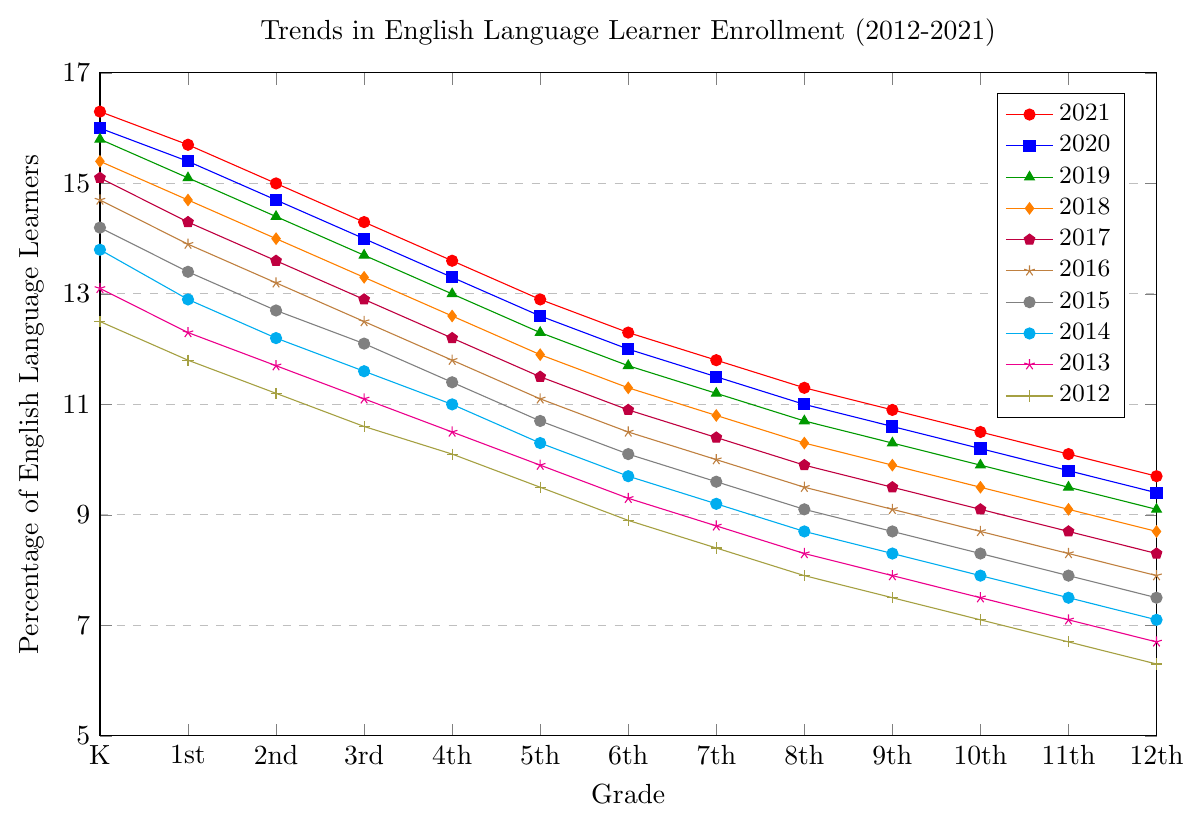What is the trend in the percentage of English Language Learners (ELL) from Kindergarten to 12th grade in the year 2021? To determine this, look at the values on the line labeled "2021" from Kindergarten (16.3%) to 12th grade (9.7%) and observe the pattern. The trend shows a decrease in the percentage of ELL from Kindergarten to 12th grade.
Answer: Decreasing trend Which grade shows the highest percentage of ELL in 2021? Refer to the values labeled "2021" and identify the highest point on the line chart. The highest percentage is at Kindergarten with 16.3%.
Answer: Kindergarten By how much did the percentage of ELL in the 6th grade change from 2012 to 2021? Look at the values for 6th grade in 2012 (8.9%) and 2021 (12.3%). Calculate the difference: 12.3% - 8.9% = 3.4%.
Answer: 3.4% Compare the percentage of ELL in the 5th grade in 2015 and 2020. Which year had a higher percentage and by how much? Examine the values for 5th grade in 2015 (10.7%) and 2020 (12.6%). 2020 had a higher percentage. Calculate the difference: 12.6% - 10.7% = 1.9%.
Answer: 2020, 1.9% What is the average percentage of ELL across all grades in 2021? Sum the percentages for all grades in 2021 (16.3 + 15.7 + 15.0 + 14.3 + 13.6 + 12.9 + 12.3 + 11.8 + 11.3 + 10.9 + 10.5 + 10.1 + 9.7) = 174.4%. There are 13 grades. Divide the sum by 13: 174.4 / 13 ≈ 13.41%.
Answer: 13.41% In which year did the 12th grade have the lowest percentage of ELL? Examine the line for 12th grade and identify the lowest value. The lowest value is in 2012 with 6.3%.
Answer: 2012 Which grade had the smallest increase in ELL percentage from 2012 to 2021? Calculate the increase for each grade: 
- Kindergarten: 16.3 - 12.5 = 3.8
- 1st: 15.7 - 11.8 = 3.9
- 2nd: 15.0 - 11.2 = 3.8
- 3rd: 14.3 - 10.6 = 3.7
- 4th: 13.6 - 10.1 = 3.5
- 5th: 12.9 - 9.5 = 3.4
- 6th: 12.3 - 8.9 = 3.4
- 7th: 11.8 - 8.4 = 3.4
- 8th: 11.3 - 7.9 = 3.4
- 9th: 10.9 - 7.5 = 3.4
- 10th: 10.5 - 7.1 = 3.4
- 11th: 10.1 - 6.7 = 3.4
- 12th: 9.7 - 6.3 = 3.4
The grade with the smallest increase is tied among 5th, 6th, 7th, 8th, 9th, 10th, 11th, and 12th grades, all with an increase of 3.4%.
Answer: 5th, 6th, 7th, 8th, 9th, 10th, 11th, 12th How did the overall trend in the percentage of ELL change from 2012 to 2021 for grades K through 12? Examine the overall trend lines for all grades from 2012 to 2021. Each grade shows an increasing trend in the percentage of ELL over the years.
Answer: Increasing trend What is the median percentage of ELL for the 3rd grade from 2012 to 2021? List the values for 3rd grade from 2012 to 2021: 10.6, 11.1, 11.6, 12.1, 12.5, 12.9, 13.3, 13.7, 14.0, 14.3. Since there are 10 values, the median is the average of the 5th and 6th values: (12.5 + 12.9) / 2 = 12.7.
Answer: 12.7 